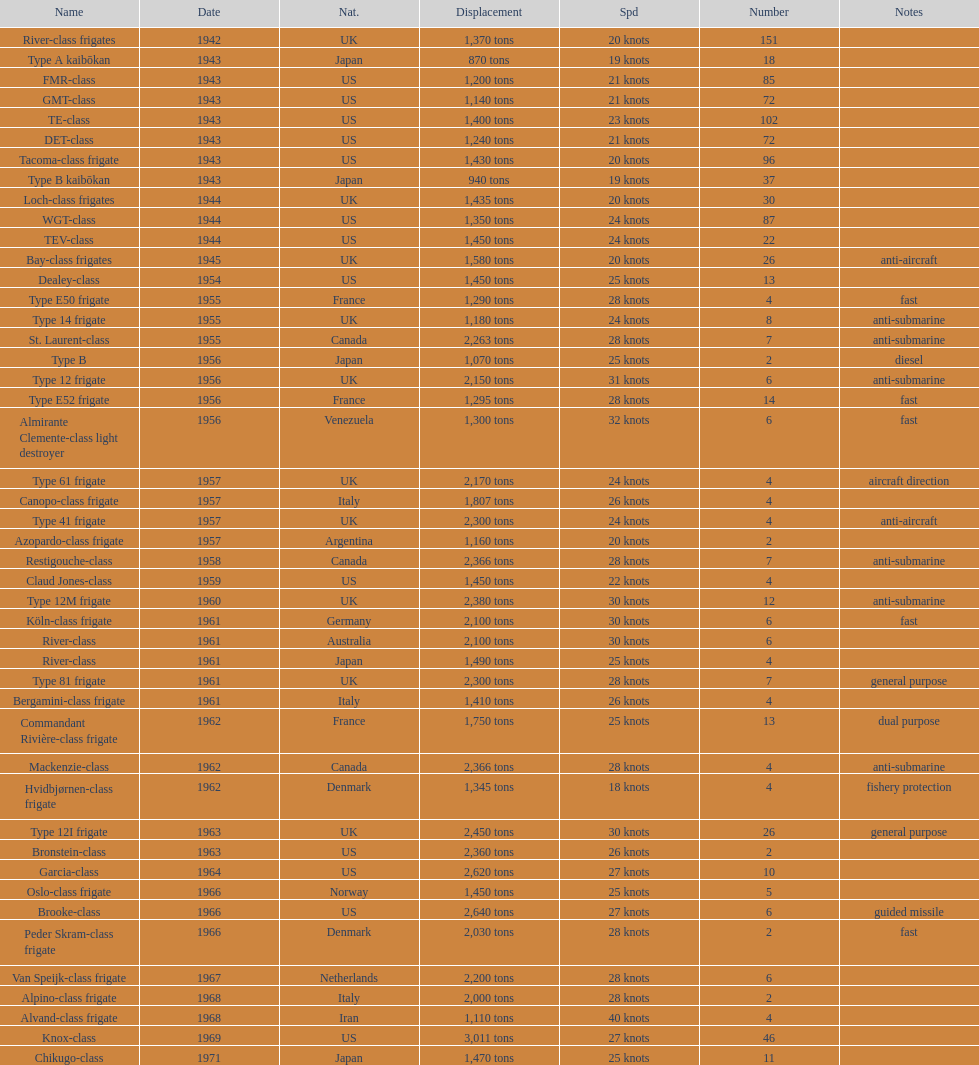How many tons of displacement does type b have? 940 tons. 